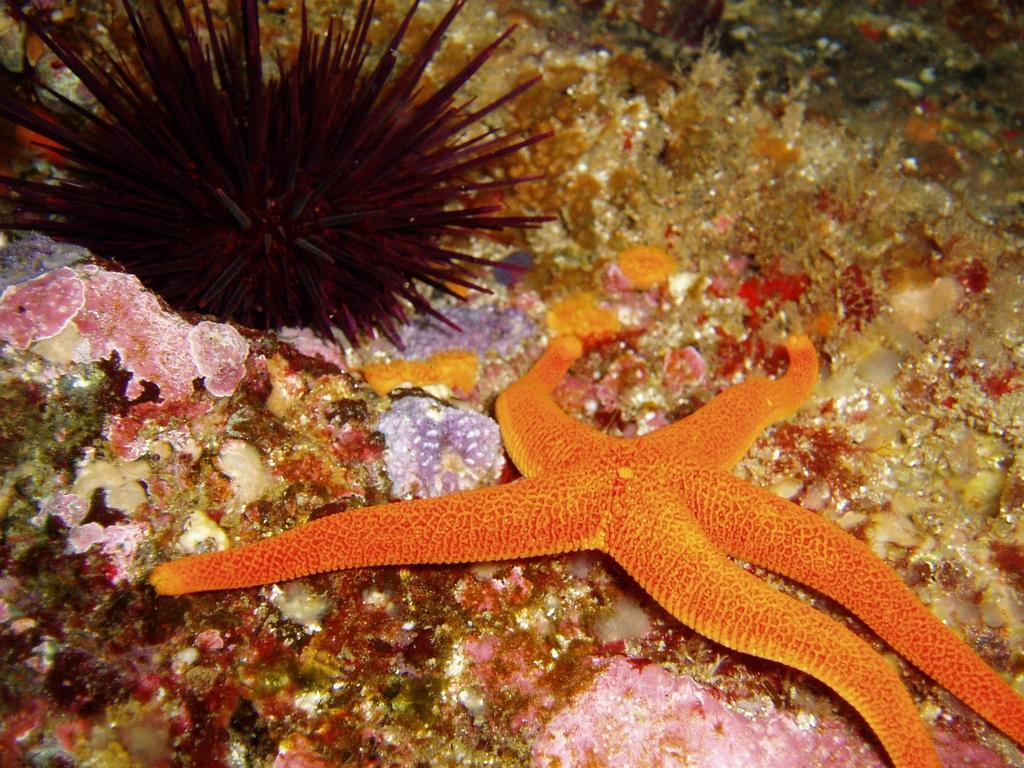What type of marine creature is in the image? There is a starfish and a sea urchin in the image. What is the ground made of in the image? The ground in the image is multi-colored. How many grains of rice are visible in the image? There are no grains of rice present in the image. What type of fruit is being held by the women in the image? There are no women or fruit present in the image. 